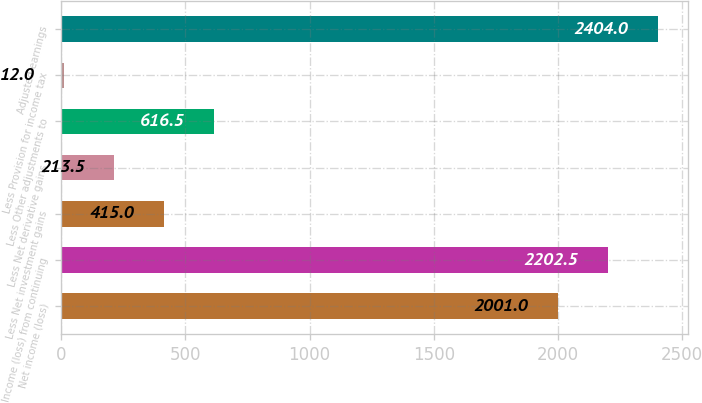Convert chart to OTSL. <chart><loc_0><loc_0><loc_500><loc_500><bar_chart><fcel>Net income (loss)<fcel>Income (loss) from continuing<fcel>Less Net investment gains<fcel>Less Net derivative gains<fcel>Less Other adjustments to<fcel>Less Provision for income tax<fcel>Adjusted earnings<nl><fcel>2001<fcel>2202.5<fcel>415<fcel>213.5<fcel>616.5<fcel>12<fcel>2404<nl></chart> 